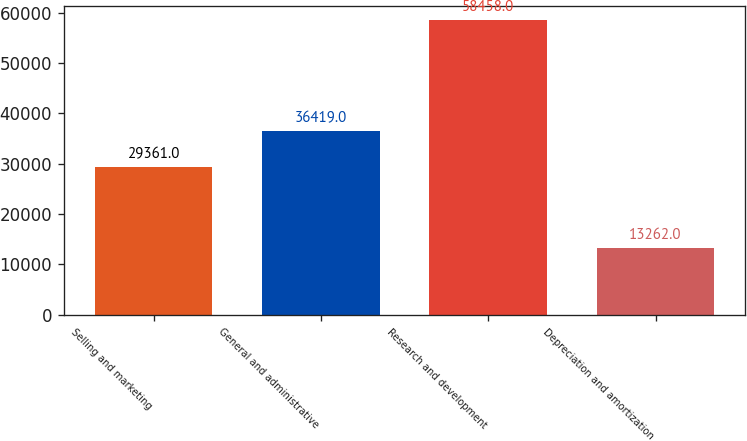<chart> <loc_0><loc_0><loc_500><loc_500><bar_chart><fcel>Selling and marketing<fcel>General and administrative<fcel>Research and development<fcel>Depreciation and amortization<nl><fcel>29361<fcel>36419<fcel>58458<fcel>13262<nl></chart> 